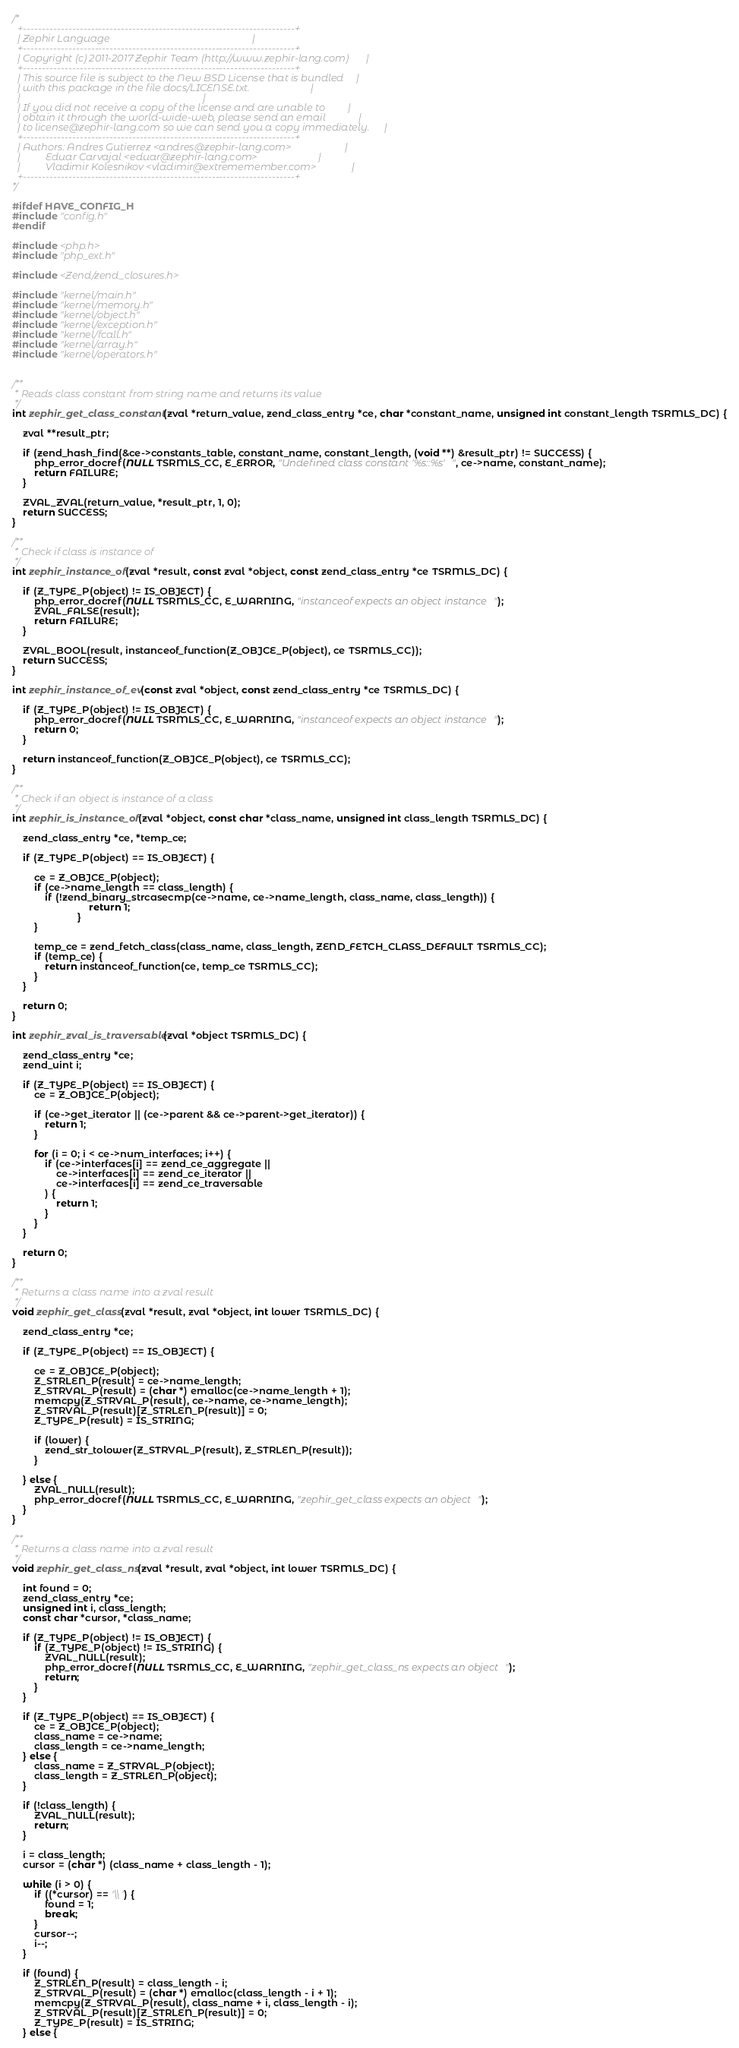<code> <loc_0><loc_0><loc_500><loc_500><_C_>
/*
  +------------------------------------------------------------------------+
  | Zephir Language                                                        |
  +------------------------------------------------------------------------+
  | Copyright (c) 2011-2017 Zephir Team (http://www.zephir-lang.com)       |
  +------------------------------------------------------------------------+
  | This source file is subject to the New BSD License that is bundled     |
  | with this package in the file docs/LICENSE.txt.                        |
  |                                                                        |
  | If you did not receive a copy of the license and are unable to         |
  | obtain it through the world-wide-web, please send an email             |
  | to license@zephir-lang.com so we can send you a copy immediately.      |
  +------------------------------------------------------------------------+
  | Authors: Andres Gutierrez <andres@zephir-lang.com>                     |
  |          Eduar Carvajal <eduar@zephir-lang.com>                        |
  |          Vladimir Kolesnikov <vladimir@extrememember.com>              |
  +------------------------------------------------------------------------+
*/

#ifdef HAVE_CONFIG_H
#include "config.h"
#endif

#include <php.h>
#include "php_ext.h"

#include <Zend/zend_closures.h>

#include "kernel/main.h"
#include "kernel/memory.h"
#include "kernel/object.h"
#include "kernel/exception.h"
#include "kernel/fcall.h"
#include "kernel/array.h"
#include "kernel/operators.h"


/**
 * Reads class constant from string name and returns its value
 */
int zephir_get_class_constant(zval *return_value, zend_class_entry *ce, char *constant_name, unsigned int constant_length TSRMLS_DC) {

	zval **result_ptr;

	if (zend_hash_find(&ce->constants_table, constant_name, constant_length, (void **) &result_ptr) != SUCCESS) {
		php_error_docref(NULL TSRMLS_CC, E_ERROR, "Undefined class constant '%s::%s'", ce->name, constant_name);
		return FAILURE;
	}

	ZVAL_ZVAL(return_value, *result_ptr, 1, 0);
	return SUCCESS;
}

/**
 * Check if class is instance of
 */
int zephir_instance_of(zval *result, const zval *object, const zend_class_entry *ce TSRMLS_DC) {

	if (Z_TYPE_P(object) != IS_OBJECT) {
		php_error_docref(NULL TSRMLS_CC, E_WARNING, "instanceof expects an object instance");
		ZVAL_FALSE(result);
		return FAILURE;
	}

	ZVAL_BOOL(result, instanceof_function(Z_OBJCE_P(object), ce TSRMLS_CC));
	return SUCCESS;
}

int zephir_instance_of_ev(const zval *object, const zend_class_entry *ce TSRMLS_DC) {

	if (Z_TYPE_P(object) != IS_OBJECT) {
		php_error_docref(NULL TSRMLS_CC, E_WARNING, "instanceof expects an object instance");
		return 0;
	}

	return instanceof_function(Z_OBJCE_P(object), ce TSRMLS_CC);
}

/**
 * Check if an object is instance of a class
 */
int zephir_is_instance_of(zval *object, const char *class_name, unsigned int class_length TSRMLS_DC) {

	zend_class_entry *ce, *temp_ce;

	if (Z_TYPE_P(object) == IS_OBJECT) {

		ce = Z_OBJCE_P(object);
		if (ce->name_length == class_length) {
		  	if (!zend_binary_strcasecmp(ce->name, ce->name_length, class_name, class_length)) {
                            return 1;
                        }
		}

		temp_ce = zend_fetch_class(class_name, class_length, ZEND_FETCH_CLASS_DEFAULT TSRMLS_CC);
		if (temp_ce) {
			return instanceof_function(ce, temp_ce TSRMLS_CC);
		}
	}

	return 0;
}

int zephir_zval_is_traversable(zval *object TSRMLS_DC) {

	zend_class_entry *ce;
	zend_uint i;

	if (Z_TYPE_P(object) == IS_OBJECT) {
		ce = Z_OBJCE_P(object);

		if (ce->get_iterator || (ce->parent && ce->parent->get_iterator)) {
			return 1;
		}

		for (i = 0; i < ce->num_interfaces; i++) {
			if (ce->interfaces[i] == zend_ce_aggregate ||
				ce->interfaces[i] == zend_ce_iterator ||
				ce->interfaces[i] == zend_ce_traversable
			) {
				return 1;
			}
		}
	}

	return 0;
}

/**
 * Returns a class name into a zval result
 */
void zephir_get_class(zval *result, zval *object, int lower TSRMLS_DC) {

	zend_class_entry *ce;

	if (Z_TYPE_P(object) == IS_OBJECT) {

		ce = Z_OBJCE_P(object);
		Z_STRLEN_P(result) = ce->name_length;
		Z_STRVAL_P(result) = (char *) emalloc(ce->name_length + 1);
		memcpy(Z_STRVAL_P(result), ce->name, ce->name_length);
		Z_STRVAL_P(result)[Z_STRLEN_P(result)] = 0;
		Z_TYPE_P(result) = IS_STRING;

		if (lower) {
			zend_str_tolower(Z_STRVAL_P(result), Z_STRLEN_P(result));
		}

	} else {
		ZVAL_NULL(result);
		php_error_docref(NULL TSRMLS_CC, E_WARNING, "zephir_get_class expects an object");
	}
}

/**
 * Returns a class name into a zval result
 */
void zephir_get_class_ns(zval *result, zval *object, int lower TSRMLS_DC) {

	int found = 0;
	zend_class_entry *ce;
	unsigned int i, class_length;
	const char *cursor, *class_name;

	if (Z_TYPE_P(object) != IS_OBJECT) {
		if (Z_TYPE_P(object) != IS_STRING) {
			ZVAL_NULL(result);
			php_error_docref(NULL TSRMLS_CC, E_WARNING, "zephir_get_class_ns expects an object");
			return;
		}
	}

	if (Z_TYPE_P(object) == IS_OBJECT) {
		ce = Z_OBJCE_P(object);
		class_name = ce->name;
		class_length = ce->name_length;
	} else {
		class_name = Z_STRVAL_P(object);
		class_length = Z_STRLEN_P(object);
	}

	if (!class_length) {
		ZVAL_NULL(result);
		return;
	}

	i = class_length;
	cursor = (char *) (class_name + class_length - 1);

	while (i > 0) {
		if ((*cursor) == '\\') {
			found = 1;
			break;
		}
		cursor--;
		i--;
	}

	if (found) {
		Z_STRLEN_P(result) = class_length - i;
		Z_STRVAL_P(result) = (char *) emalloc(class_length - i + 1);
		memcpy(Z_STRVAL_P(result), class_name + i, class_length - i);
		Z_STRVAL_P(result)[Z_STRLEN_P(result)] = 0;
		Z_TYPE_P(result) = IS_STRING;
	} else {</code> 